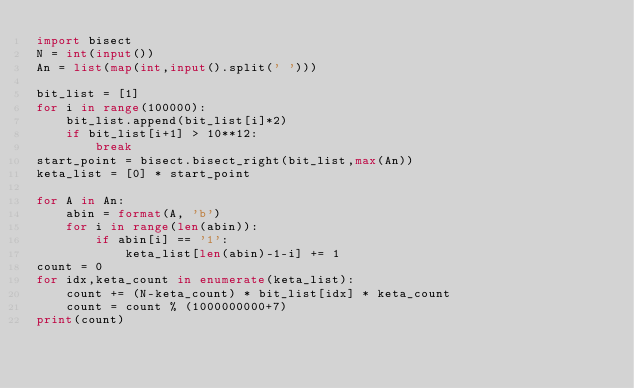Convert code to text. <code><loc_0><loc_0><loc_500><loc_500><_Python_>import bisect
N = int(input())
An = list(map(int,input().split(' '))) 

bit_list = [1]
for i in range(100000):
    bit_list.append(bit_list[i]*2)
    if bit_list[i+1] > 10**12:
        break
start_point = bisect.bisect_right(bit_list,max(An))
keta_list = [0] * start_point

for A in An:
    abin = format(A, 'b')
    for i in range(len(abin)):
        if abin[i] == '1':
            keta_list[len(abin)-1-i] += 1
count = 0
for idx,keta_count in enumerate(keta_list):
    count += (N-keta_count) * bit_list[idx] * keta_count
    count = count % (1000000000+7)
print(count)</code> 